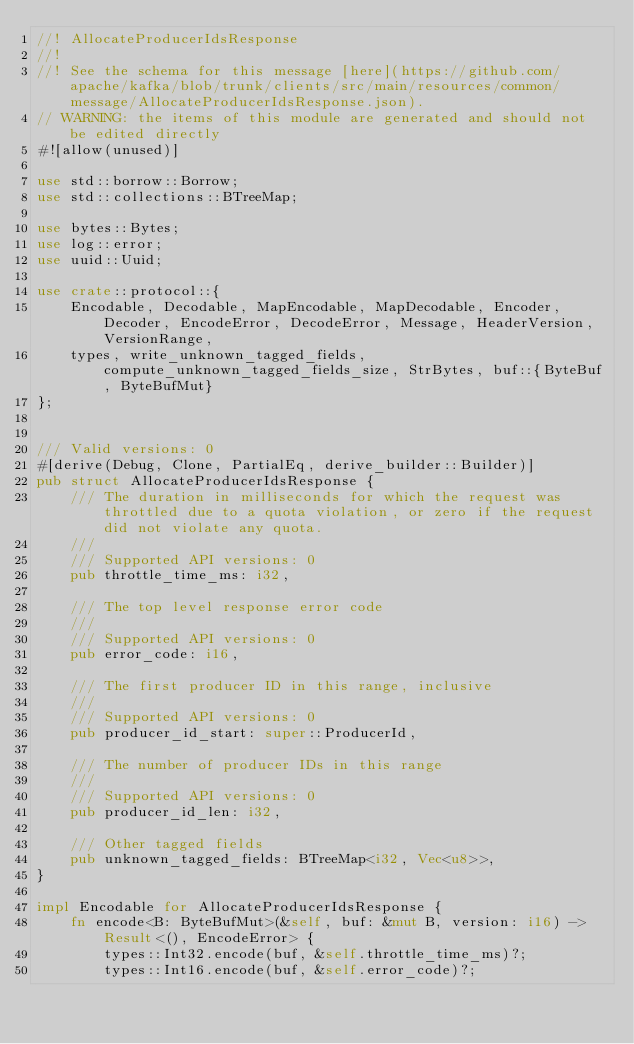Convert code to text. <code><loc_0><loc_0><loc_500><loc_500><_Rust_>//! AllocateProducerIdsResponse
//!
//! See the schema for this message [here](https://github.com/apache/kafka/blob/trunk/clients/src/main/resources/common/message/AllocateProducerIdsResponse.json).
// WARNING: the items of this module are generated and should not be edited directly
#![allow(unused)]

use std::borrow::Borrow;
use std::collections::BTreeMap;

use bytes::Bytes;
use log::error;
use uuid::Uuid;

use crate::protocol::{
    Encodable, Decodable, MapEncodable, MapDecodable, Encoder, Decoder, EncodeError, DecodeError, Message, HeaderVersion, VersionRange,
    types, write_unknown_tagged_fields, compute_unknown_tagged_fields_size, StrBytes, buf::{ByteBuf, ByteBufMut}
};


/// Valid versions: 0
#[derive(Debug, Clone, PartialEq, derive_builder::Builder)]
pub struct AllocateProducerIdsResponse {
    /// The duration in milliseconds for which the request was throttled due to a quota violation, or zero if the request did not violate any quota.
    /// 
    /// Supported API versions: 0
    pub throttle_time_ms: i32,

    /// The top level response error code
    /// 
    /// Supported API versions: 0
    pub error_code: i16,

    /// The first producer ID in this range, inclusive
    /// 
    /// Supported API versions: 0
    pub producer_id_start: super::ProducerId,

    /// The number of producer IDs in this range
    /// 
    /// Supported API versions: 0
    pub producer_id_len: i32,

    /// Other tagged fields
    pub unknown_tagged_fields: BTreeMap<i32, Vec<u8>>,
}

impl Encodable for AllocateProducerIdsResponse {
    fn encode<B: ByteBufMut>(&self, buf: &mut B, version: i16) -> Result<(), EncodeError> {
        types::Int32.encode(buf, &self.throttle_time_ms)?;
        types::Int16.encode(buf, &self.error_code)?;</code> 